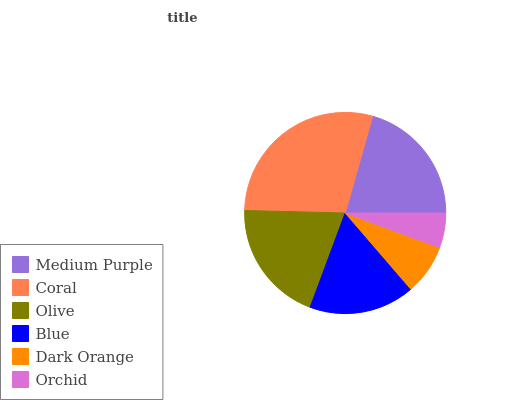Is Orchid the minimum?
Answer yes or no. Yes. Is Coral the maximum?
Answer yes or no. Yes. Is Olive the minimum?
Answer yes or no. No. Is Olive the maximum?
Answer yes or no. No. Is Coral greater than Olive?
Answer yes or no. Yes. Is Olive less than Coral?
Answer yes or no. Yes. Is Olive greater than Coral?
Answer yes or no. No. Is Coral less than Olive?
Answer yes or no. No. Is Olive the high median?
Answer yes or no. Yes. Is Blue the low median?
Answer yes or no. Yes. Is Medium Purple the high median?
Answer yes or no. No. Is Olive the low median?
Answer yes or no. No. 